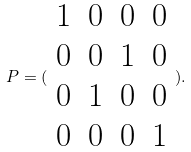<formula> <loc_0><loc_0><loc_500><loc_500>P = ( \begin{array} { c c c c } 1 & 0 & 0 & 0 \\ 0 & 0 & 1 & 0 \\ 0 & 1 & 0 & 0 \\ 0 & 0 & 0 & 1 \end{array} ) .</formula> 